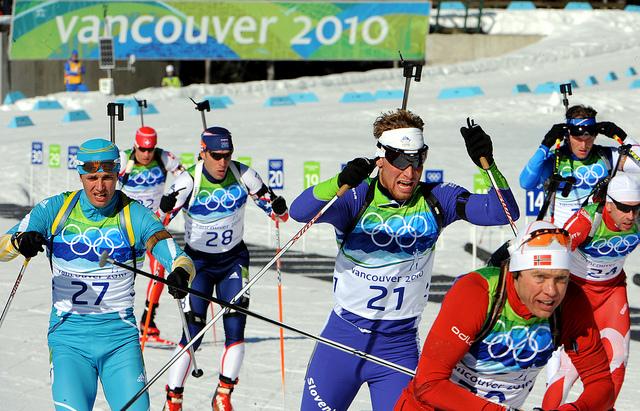Is any skier smiling?
Write a very short answer. No. What year did this event take place?
Write a very short answer. 2010. How many persons have glasses?
Write a very short answer. 7. How many people are wearing gloves?
Keep it brief. 7. 